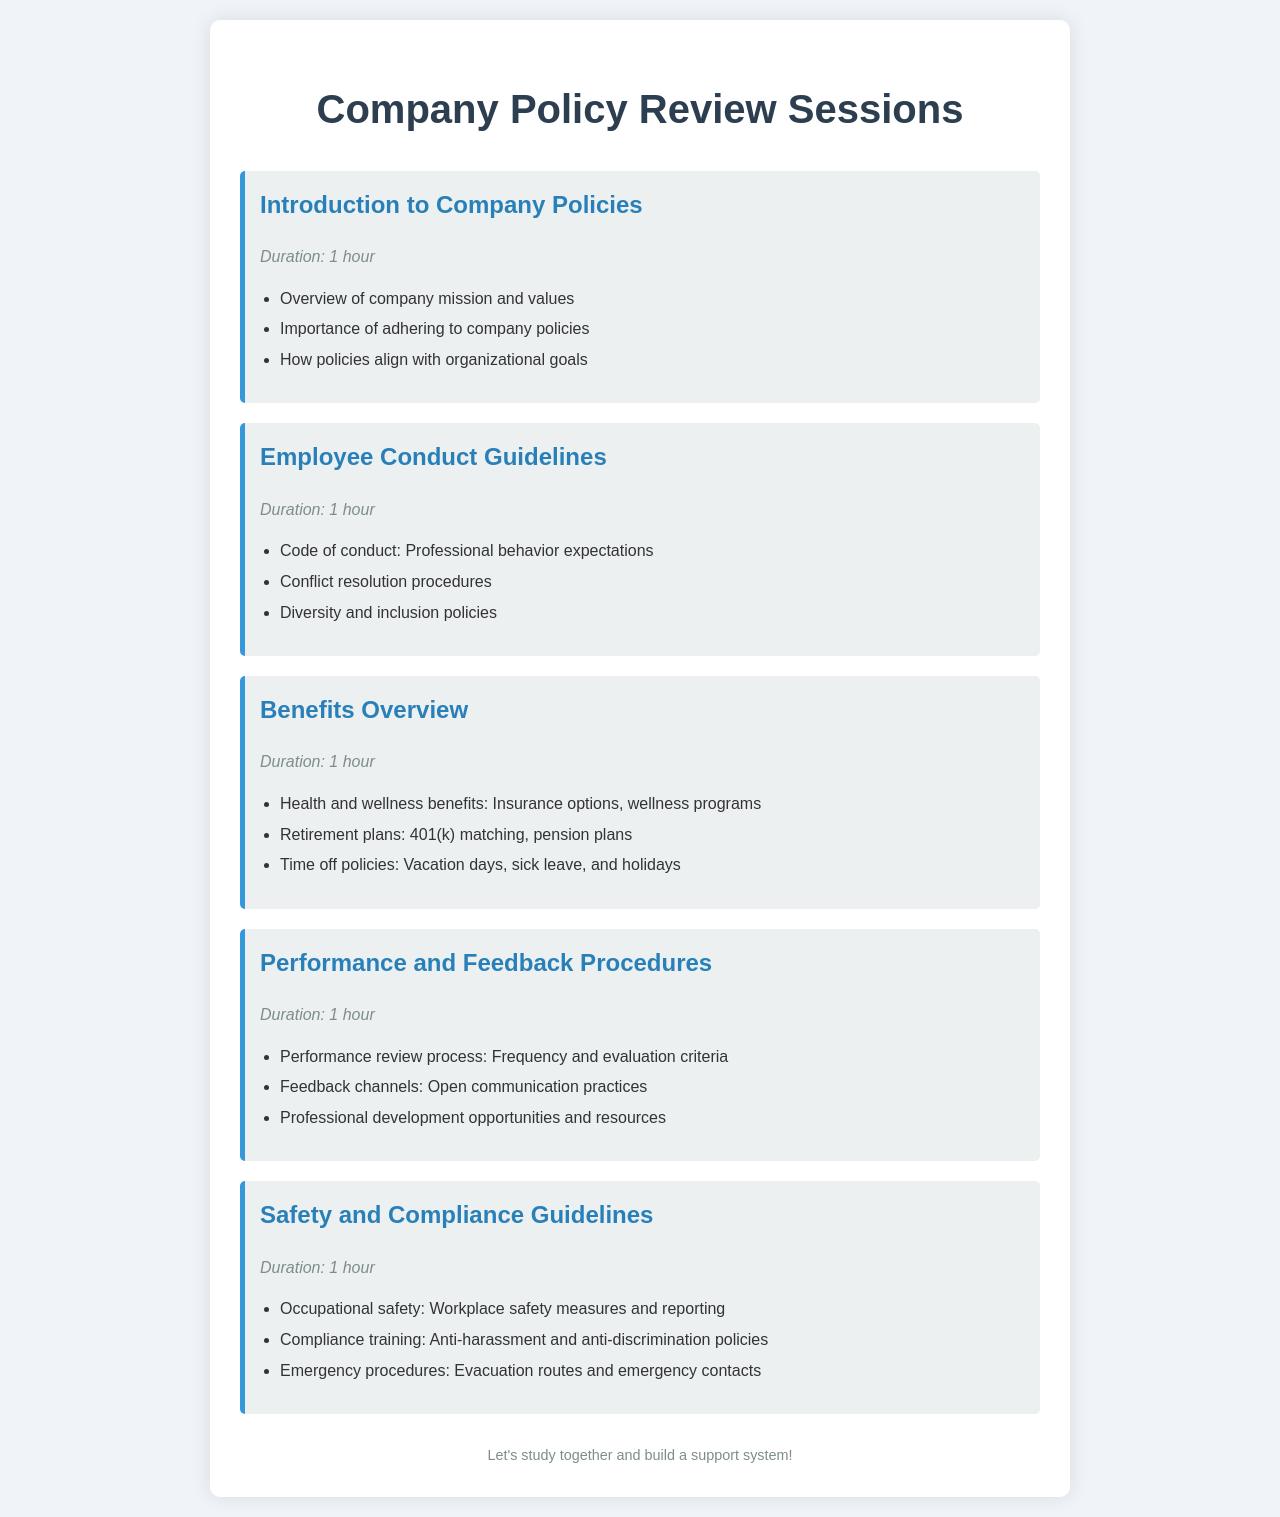What is the duration of the "Introduction to Company Policies" session? The duration is specified as 1 hour in the document.
Answer: 1 hour What are the three main points covered in the "Employee Conduct Guidelines" session? The session outlines three key areas: Code of conduct, Conflict resolution procedures, and Diversity and inclusion policies.
Answer: Code of conduct, Conflict resolution procedures, Diversity and inclusion policies What benefits are discussed in the "Benefits Overview" session? The session includes Health and wellness benefits, Retirement plans, and Time off policies as key points.
Answer: Health and wellness benefits, Retirement plans, Time off policies How many hours are allocated for each session in the company policy review? Each session is specified to last for 1 hour according to the document.
Answer: 1 hour What is one of the main topics under "Safety and Compliance Guidelines"? The document lists Occupational safety as a main topic in this session.
Answer: Occupational safety What does the "Performance and Feedback Procedures" session entail regarding feedback? It emphasizes Open communication practices as part of feedback channels in the session.
Answer: Open communication practices Which session covers emergency procedures? The "Safety and Compliance Guidelines" session includes information about emergency procedures.
Answer: Safety and Compliance Guidelines What is the general theme of the document? The document focuses on company policy review sessions that cover various employee guidelines and benefits.
Answer: Company policy review sessions 